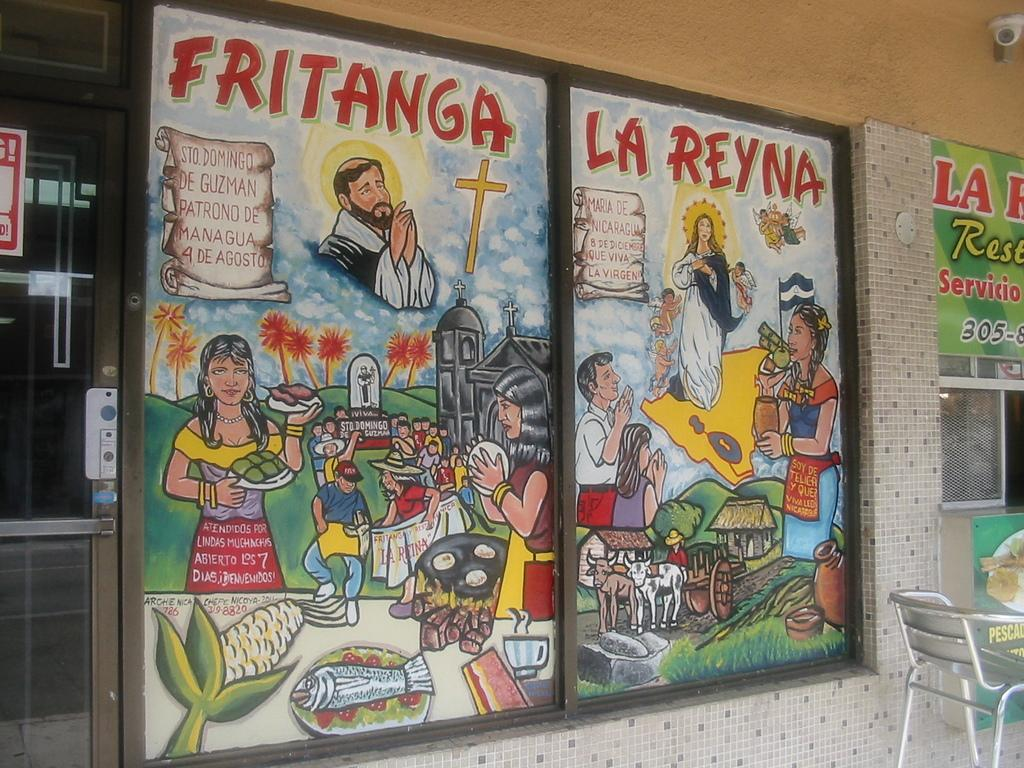<image>
Provide a brief description of the given image. A window at a restaurant depicts a religious scene with the words Fritanga and La Reyna at the tops. 